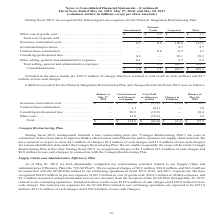According to Conagra Brands's financial document, What does the table show us in the fiscal year 2019? pre-tax expenses for the Pinnacle Integration Restructuring Plan. The document states: "During fiscal 2019, we recognized the following pre-tax expenses for the Pinnacle Integration Restructuring Plan:..." Also, How much were the non-cash charges included in the pre-tax expenses? Based on the financial document, the answer is $4.7 million. Also, What were the consolidated totals of International and Pinnacle Foods, respectively? The document shows two values: $1.0 and $5.1 (in millions). From the document: "al selling, general and administrative expenses . 1.0 1.4 162.1 164.5 Consolidated total. . $ 1.0 $ 5.1 $ 162.1 $ 168.2..." Also, can you calculate: What is the proportion of cash charges that have resulted or will result in cash outflows over total consolidated pre-tax expenses? Based on the calculation: 163.5/168.2 , the result is 0.97. This is based on the information: "Consolidated total. . $ 1.0 $ 5.1 $ 162.1 $ 168.2 Included in the above results are $163.5 million of charges that have resulted or will result in cash outflows and $4.7..." The key data points involved are: 163.5, 168.2. Also, can you calculate: What is the proportion of accelerated depreciation, contract/lease termination, and consulting/professional fees over the consolidated total in the Corporate segment? To answer this question, I need to perform calculations using the financial data. The calculation is: (4.7+0.3+38.1)/162.1 , which equals 0.27. This is based on the information: "Accelerated depreciation . — — 4.7 4.7 Consulting/professional fees . 0.2 — 38.1 38.3 Contract/lease termination. . — 0.8 0.3 1.1 ng, general and administrative expenses . 1.0 1.4 162.1 164.5..." The key data points involved are: 0.3, 162.1, 38.1. Also, can you calculate: What is the ratio of International’s consolidated total to Pinnacle Foods’ consolidated total? Based on the calculation: 1.0/5.1 , the result is 0.2. This is based on the information: "al selling, general and administrative expenses . 1.0 1.4 162.1 164.5 Consolidated total. . $ 1.0 $ 5.1 $ 162.1 $ 168.2..." The key data points involved are: 1.0, 5.1. 